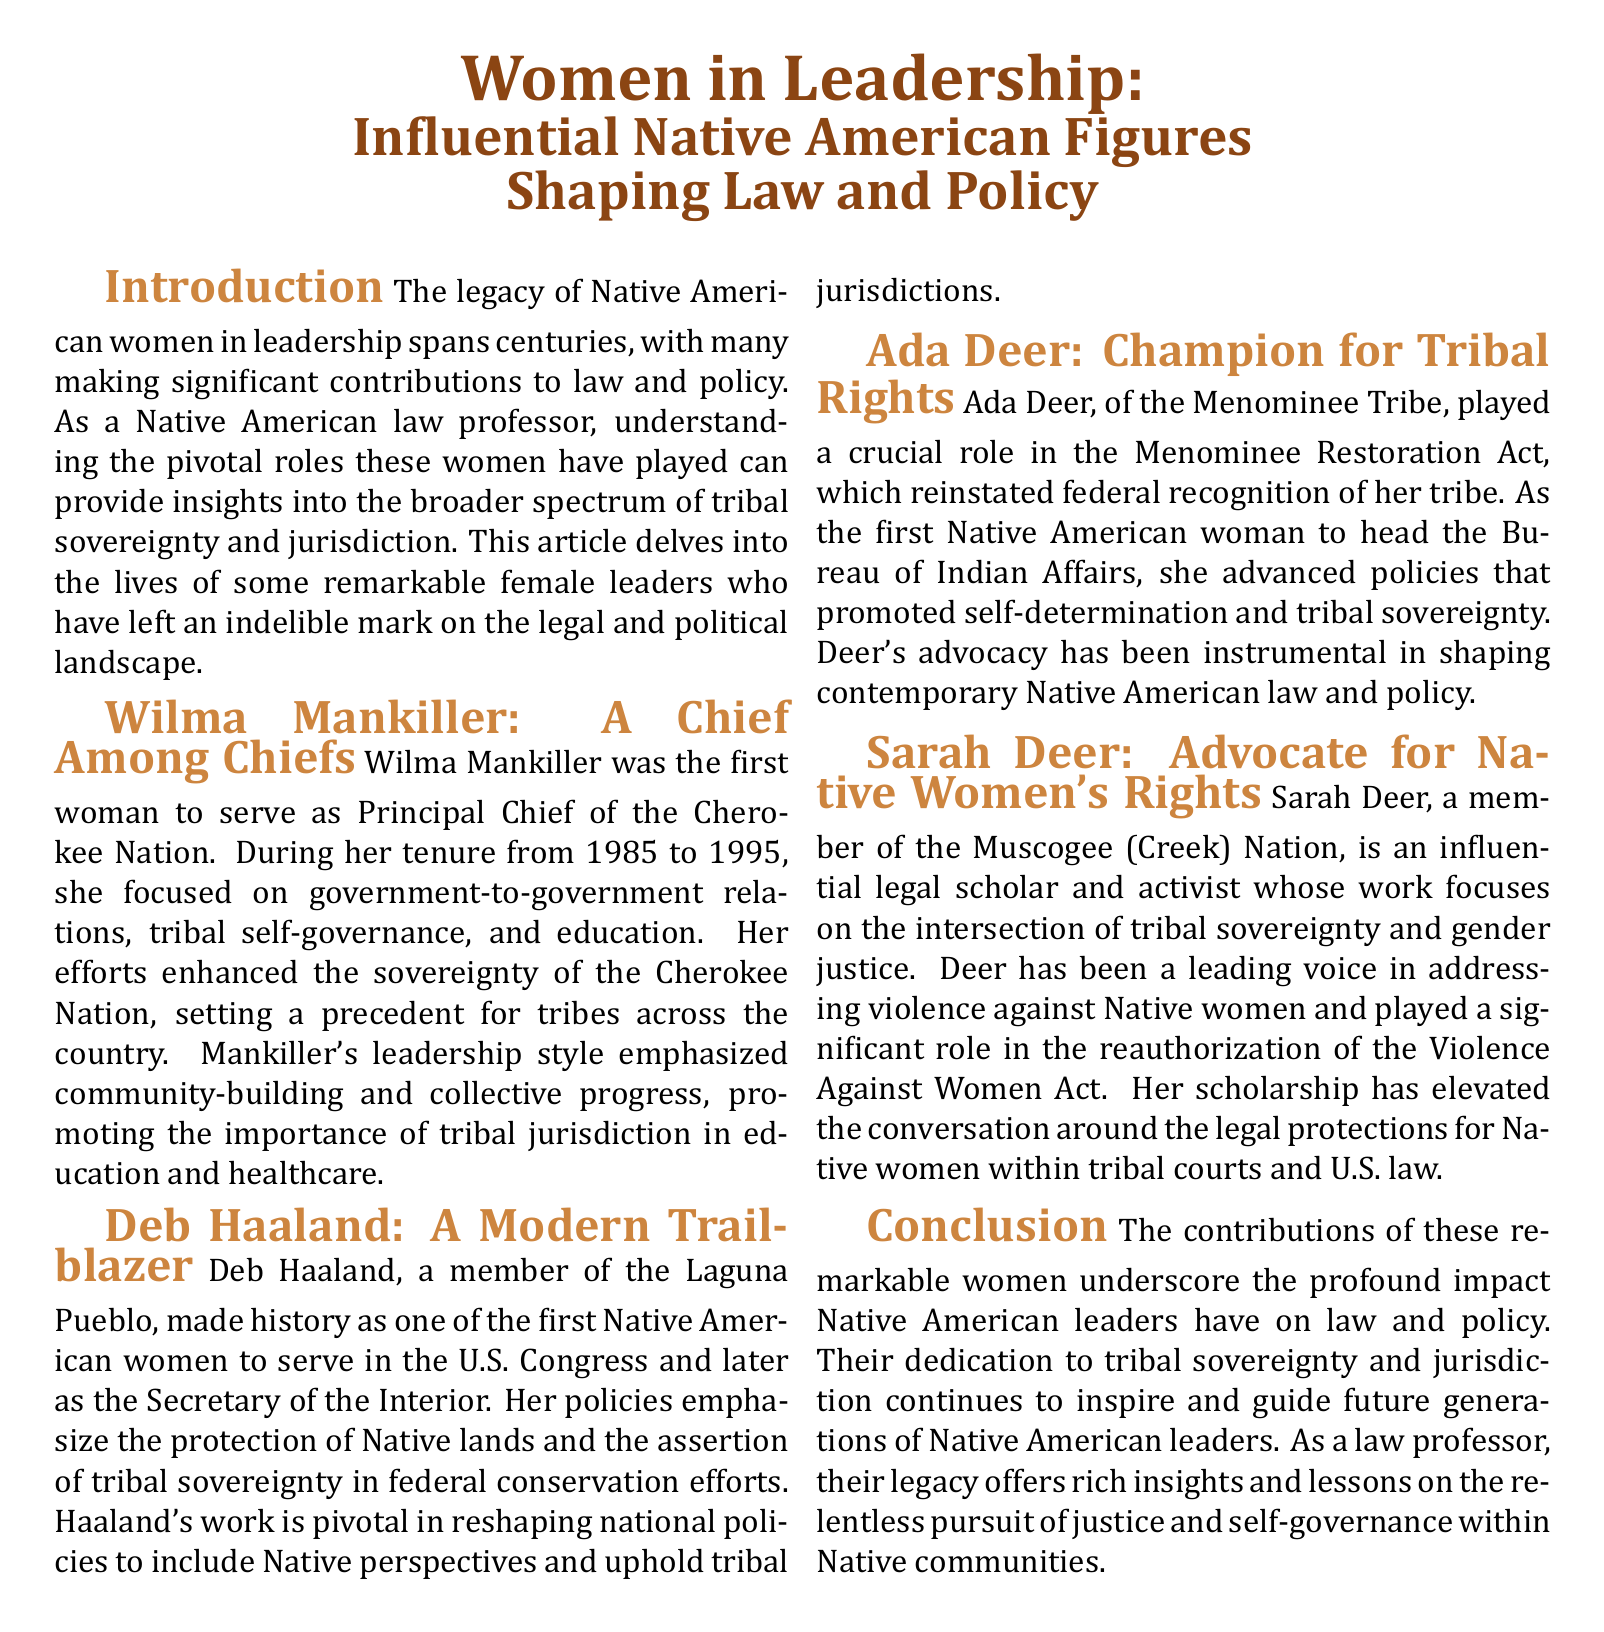What leadership position did Wilma Mankiller hold? Wilma Mankiller was the first woman to serve as Principal Chief of the Cherokee Nation.
Answer: Principal Chief What tribe is Deb Haaland a member of? Deb Haaland is a member of the Laguna Pueblo tribe.
Answer: Laguna Pueblo What important act did Ada Deer help advance? Ada Deer played a crucial role in the Menominee Restoration Act.
Answer: Menominee Restoration Act In what area does Sarah Deer focus her scholarship? Sarah Deer focuses her scholarship on the intersection of tribal sovereignty and gender justice.
Answer: Tribal sovereignty and gender justice What years did Wilma Mankiller serve as Principal Chief? Wilma Mankiller served from 1985 to 1995.
Answer: 1985 to 1995 What significant legislation did Sarah Deer contribute to? Sarah Deer played a significant role in the reauthorization of the Violence Against Women Act.
Answer: Violence Against Women Act Which figure was the first Native American woman to head the Bureau of Indian Affairs? Ada Deer was the first Native American woman to head the Bureau of Indian Affairs.
Answer: Ada Deer What is the main theme of the article? The main theme of the article is about influential Native American women shaping law and policy.
Answer: Influential Native American women shaping law and policy What type of governance did Wilma Mankiller emphasize? Wilma Mankiller emphasized tribal self-governance.
Answer: Tribal self-governance 